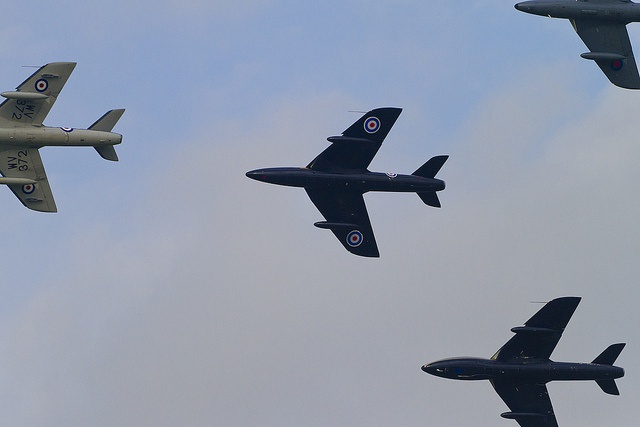Describe the objects in this image and their specific colors. I can see airplane in darkgray, black, navy, and gray tones, airplane in darkgray, black, and gray tones, airplane in darkgray, gray, and black tones, and airplane in darkgray, black, darkblue, and gray tones in this image. 